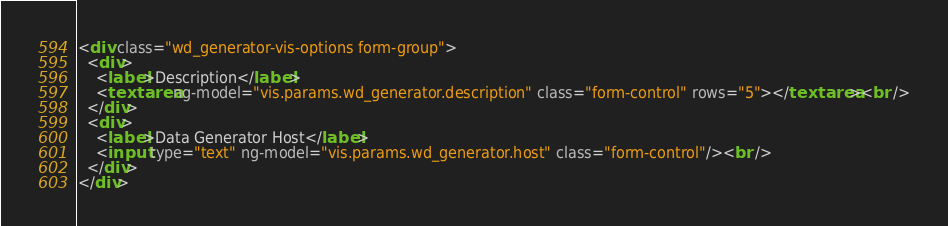Convert code to text. <code><loc_0><loc_0><loc_500><loc_500><_HTML_><div class="wd_generator-vis-options form-group">
  <div>
    <label>Description</label>
    <textarea ng-model="vis.params.wd_generator.description" class="form-control" rows="5"></textarea><br />
  </div>
  <div>
    <label>Data Generator Host</label>
    <input type="text" ng-model="vis.params.wd_generator.host" class="form-control"/><br />
  </div>
</div></code> 